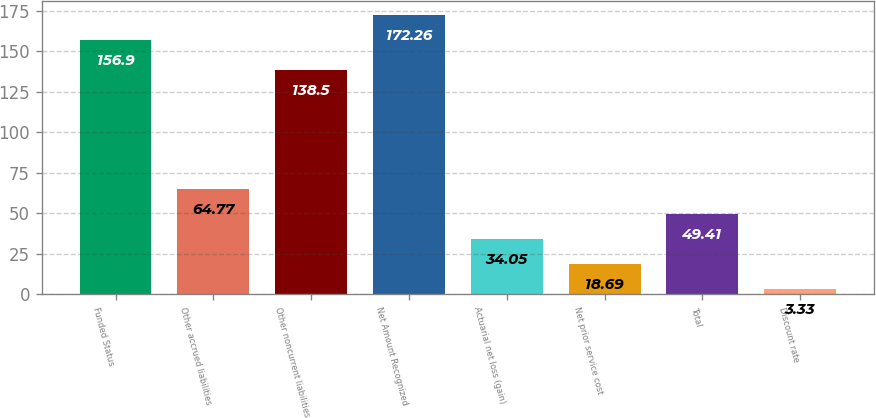Convert chart to OTSL. <chart><loc_0><loc_0><loc_500><loc_500><bar_chart><fcel>Funded Status<fcel>Other accrued liabilities<fcel>Other noncurrent liabilities<fcel>Net Amount Recognized<fcel>Actuarial net loss (gain)<fcel>Net prior service cost<fcel>Total<fcel>Discount rate<nl><fcel>156.9<fcel>64.77<fcel>138.5<fcel>172.26<fcel>34.05<fcel>18.69<fcel>49.41<fcel>3.33<nl></chart> 